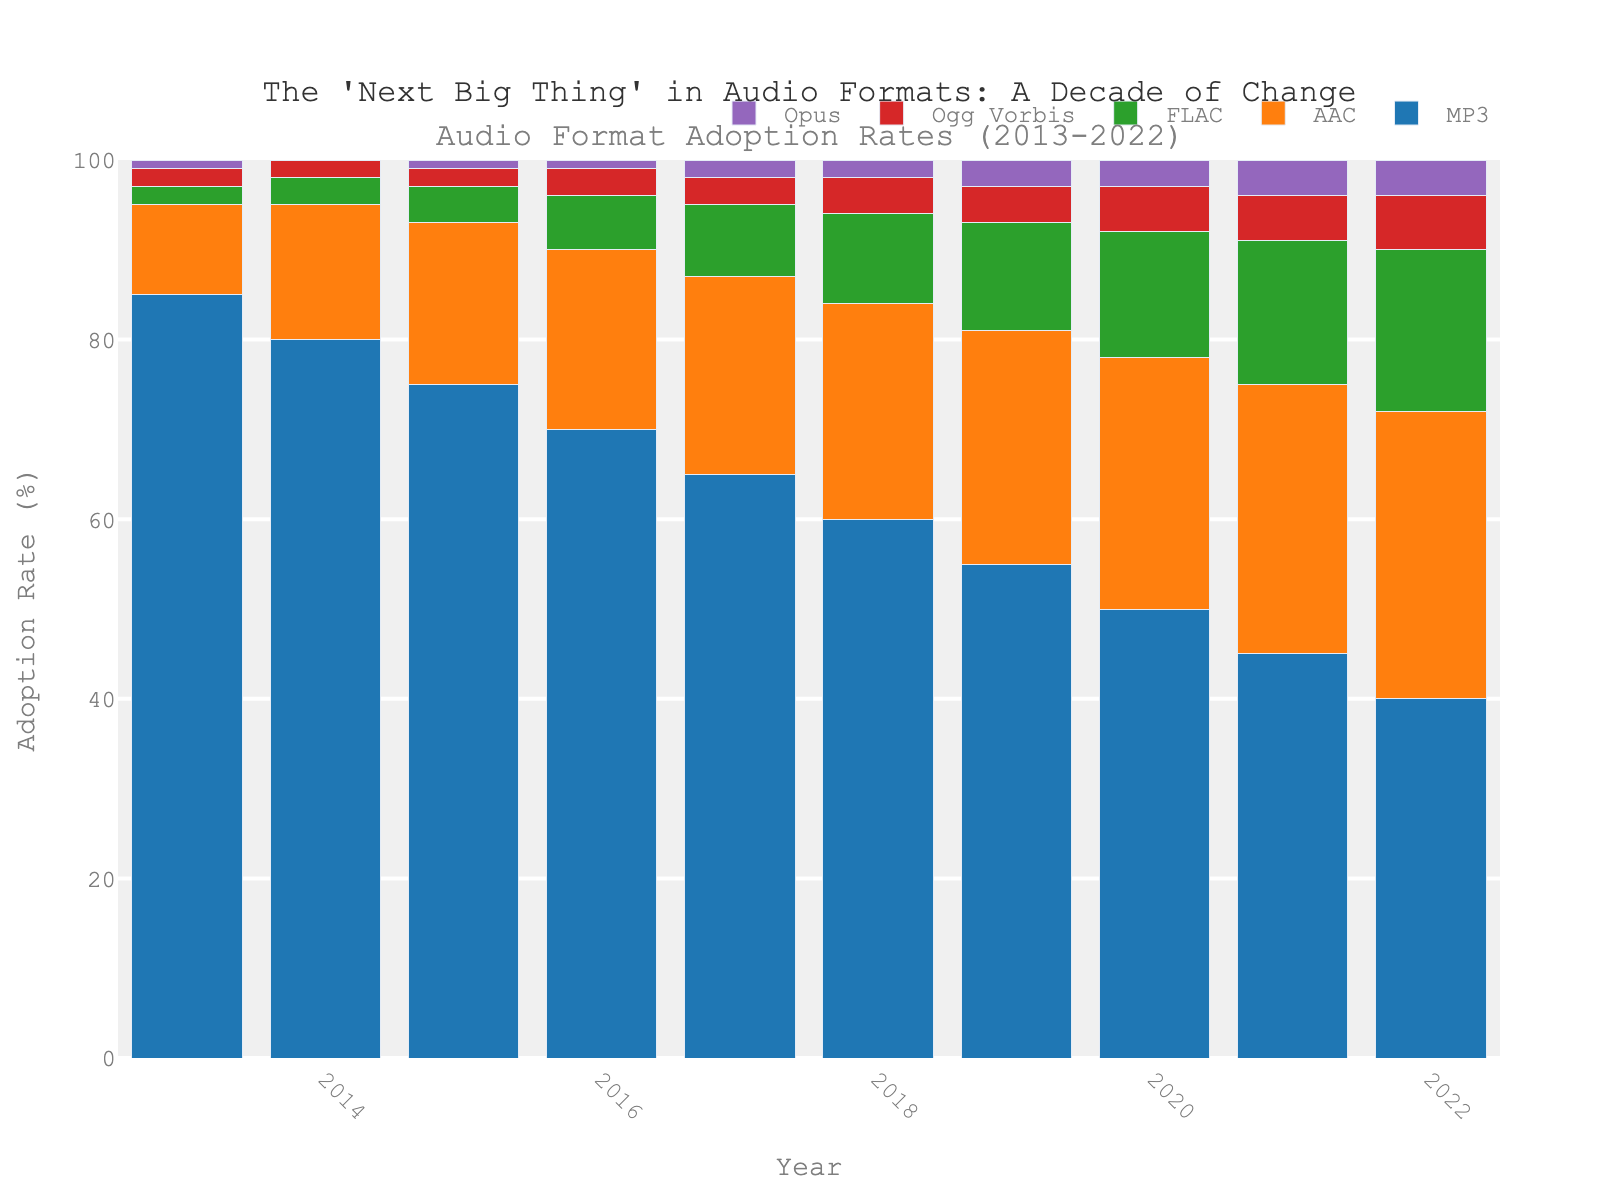What is the most adopted audio format in 2022? The highest bar in 2022 is for MP3, which means it is the most adopted format that year.
Answer: MP3 Which audio format had the least adoption rate in 2015? The shortest bar in 2015 is for Opus, indicating it had the least adoption rate.
Answer: Opus How did the adoption rate of FLAC change from 2013 to 2022? In 2013, the FLAC adoption rate was 2%, and it increased every year until reaching 18% in 2022.
Answer: Increased by 16% What is the difference in AAC's adoption rate between 2013 and 2018? AAC's adoption rate in 2013 was 10%. In 2018, it was 24%. The difference is 24% - 10%.
Answer: 14% Which audio format showed the most consistent adoption rate over the decade? Ogg Vorbis adoption rate started at 2% in 2013 and slowly increased to 6% by 2022, showing the smallest changes compared to other formats.
Answer: Ogg Vorbis What is the average adoption rate of MP3 over the decade? Sum the yearly adoption rates of MP3 from 2013 to 2022 (85 + 80 + 75 + 70 + 65 + 60 + 55 + 50 + 45 + 40), then divide by the number of years (10). Average = (85 + 80 + 75 + 70 + 65 + 60 + 55 + 50 + 45 + 40)/ 10 = 62.5%
Answer: 62.5% Which two audio formats had their adoption rates intersect between 2016 and 2017? MP3 and AAC's adoption rates show a point of intersection between 2016 (70%) and 2017 (65% for MP3, 22% for AAC). This means they intersected around this period as AAC steeply increased while MP3 declined.
Answer: MP3 and AAC How much did the adoption rate of Opus grow from 2013 to 2022? Opus had a 1% adoption rate in 2013 and increased to 4% in 2022. The growth is 4% - 1%.
Answer: 3% If the trends continue, which audio format is likely to surpass MP3 in adoption rate next and when might it happen? AAC is the closest to MP3, with a steep increasing trend. It increased from 10% in 2013 to 32% in 2022, while MP3 decreased from 85% to 40%. At this rate, if trends continue, AAC may surpass MP3 in the next few years, possibly around 2025-2026.
Answer: AAC around 2025-2026 